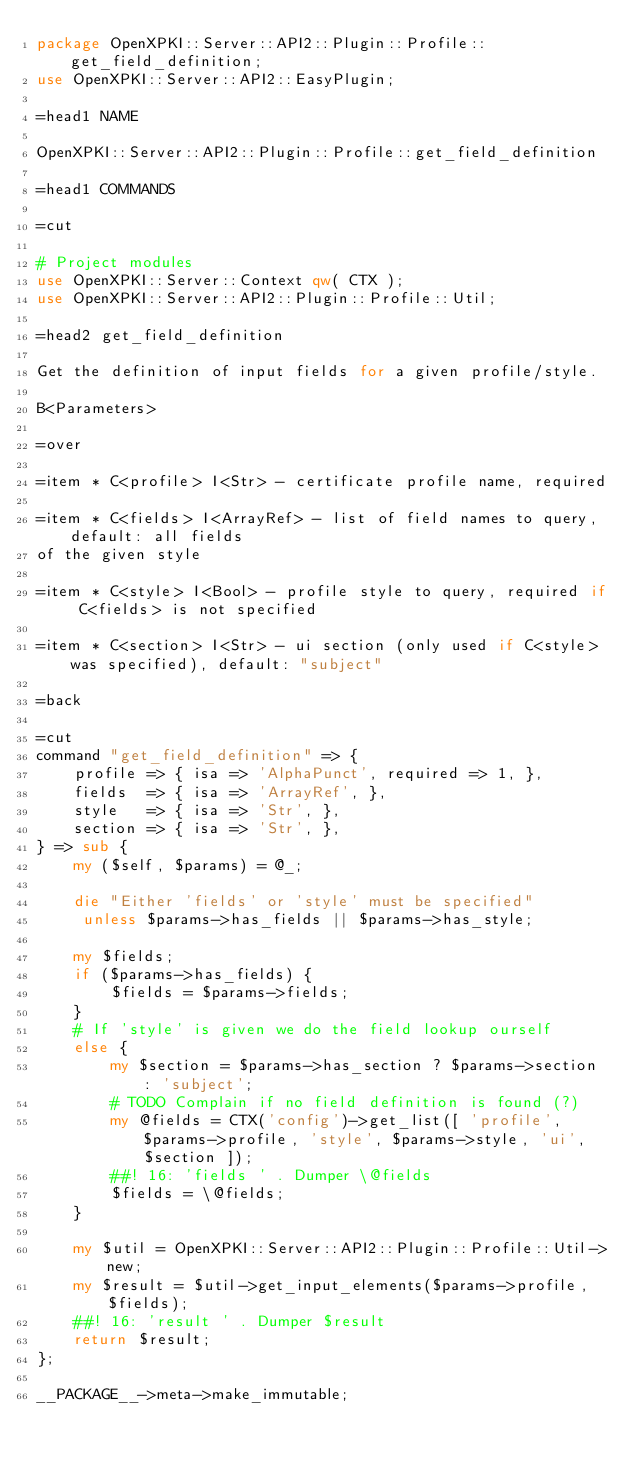<code> <loc_0><loc_0><loc_500><loc_500><_Perl_>package OpenXPKI::Server::API2::Plugin::Profile::get_field_definition;
use OpenXPKI::Server::API2::EasyPlugin;

=head1 NAME

OpenXPKI::Server::API2::Plugin::Profile::get_field_definition

=head1 COMMANDS

=cut

# Project modules
use OpenXPKI::Server::Context qw( CTX );
use OpenXPKI::Server::API2::Plugin::Profile::Util;

=head2 get_field_definition

Get the definition of input fields for a given profile/style.

B<Parameters>

=over

=item * C<profile> I<Str> - certificate profile name, required

=item * C<fields> I<ArrayRef> - list of field names to query, default: all fields
of the given style

=item * C<style> I<Bool> - profile style to query, required if C<fields> is not specified

=item * C<section> I<Str> - ui section (only used if C<style> was specified), default: "subject"

=back

=cut
command "get_field_definition" => {
    profile => { isa => 'AlphaPunct', required => 1, },
    fields  => { isa => 'ArrayRef', },
    style   => { isa => 'Str', },
    section => { isa => 'Str', },
} => sub {
    my ($self, $params) = @_;

    die "Either 'fields' or 'style' must be specified"
     unless $params->has_fields || $params->has_style;

    my $fields;
    if ($params->has_fields) {
        $fields = $params->fields;
    }
    # If 'style' is given we do the field lookup ourself
    else {
        my $section = $params->has_section ? $params->section : 'subject';
        # TODO Complain if no field definition is found (?)
        my @fields = CTX('config')->get_list([ 'profile', $params->profile, 'style', $params->style, 'ui', $section ]);
        ##! 16: 'fields ' . Dumper \@fields
        $fields = \@fields;
    }

    my $util = OpenXPKI::Server::API2::Plugin::Profile::Util->new;
    my $result = $util->get_input_elements($params->profile, $fields);
    ##! 16: 'result ' . Dumper $result
    return $result;
};

__PACKAGE__->meta->make_immutable;
</code> 